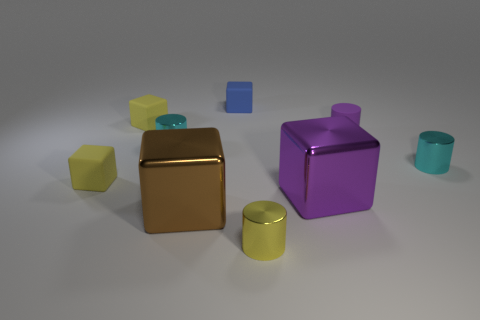Are there any objects here that might indicate scale? Without standard reference objects like a coin or a ruler, it's challenging to determine exact scale. However, judging by the proportions and assuming these objects conform to common geometrical sizes, one might infer they are of a size that could easily be held in one's hand. 